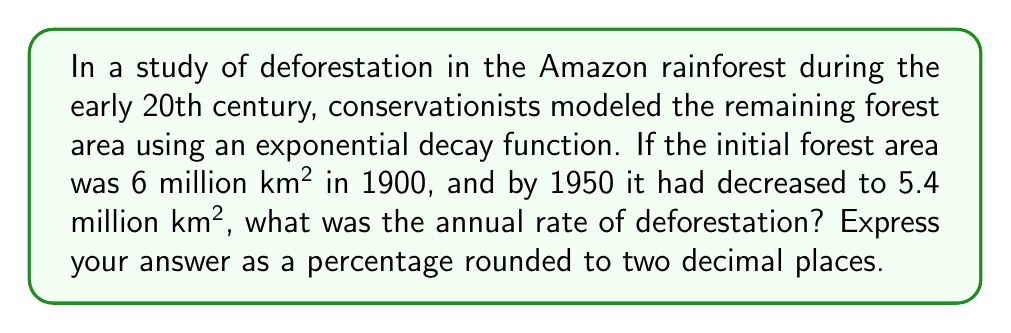Teach me how to tackle this problem. Let's approach this step-by-step using the exponential decay model:

1) The general form of exponential decay is:
   $$A(t) = A_0 e^{-rt}$$
   where $A(t)$ is the amount at time $t$, $A_0$ is the initial amount, $r$ is the decay rate, and $t$ is the time.

2) We know:
   $A_0 = 6$ million km² (initial area in 1900)
   $A(50) = 5.4$ million km² (area after 50 years, in 1950)
   $t = 50$ years

3) Plugging these into our equation:
   $$5.4 = 6e^{-50r}$$

4) Divide both sides by 6:
   $$\frac{5.4}{6} = e^{-50r}$$

5) Take the natural log of both sides:
   $$\ln(\frac{5.4}{6}) = -50r$$

6) Solve for $r$:
   $$r = -\frac{\ln(\frac{5.4}{6})}{50}$$

7) Calculate:
   $$r = -\frac{\ln(0.9)}{50} \approx 0.0021$$

8) Convert to a percentage:
   $$0.0021 * 100 \approx 0.21\%$$

Thus, the annual rate of deforestation was approximately 0.21%.
Answer: 0.21% 